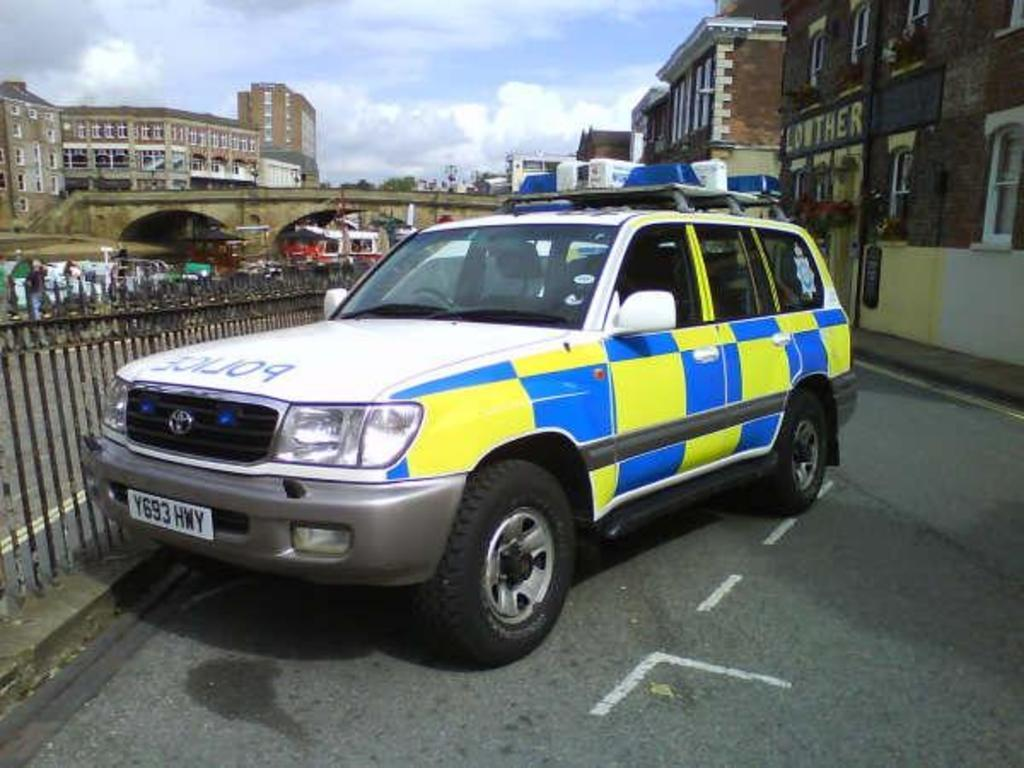What is the main subject of the image? There is a vehicle in the image. Where is the vehicle located? The vehicle is parked on the road. What can be seen in the background of the image? There are buildings visible behind the vehicle. What type of animals can be seen at the zoo in the image? There is no zoo present in the image; it features a parked vehicle and buildings in the background. What material is the iron used for in the image? There is no iron present in the image. 